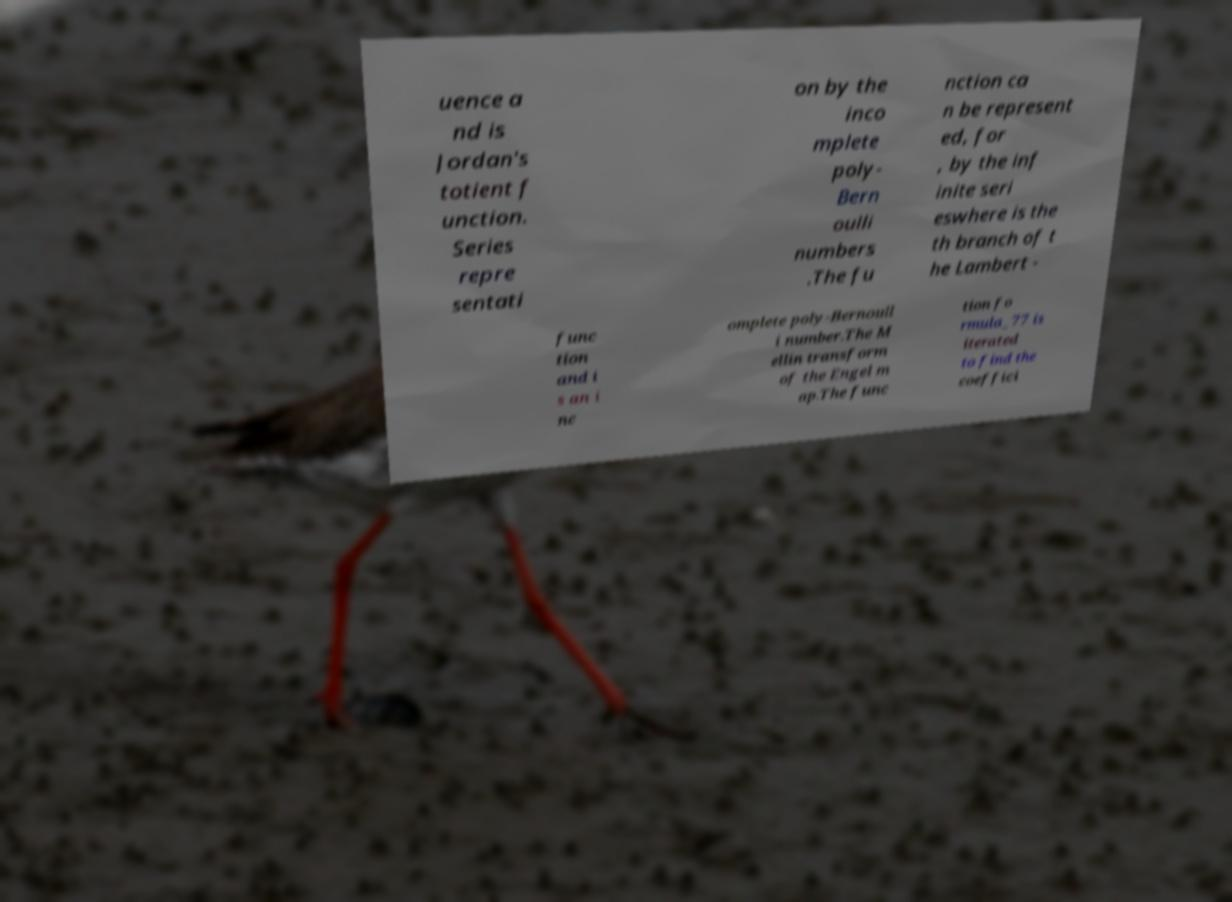What messages or text are displayed in this image? I need them in a readable, typed format. uence a nd is Jordan's totient f unction. Series repre sentati on by the inco mplete poly- Bern oulli numbers .The fu nction ca n be represent ed, for , by the inf inite seri eswhere is the th branch of t he Lambert - func tion and i s an i nc omplete poly-Bernoull i number.The M ellin transform of the Engel m ap.The func tion fo rmula_77 is iterated to find the coeffici 